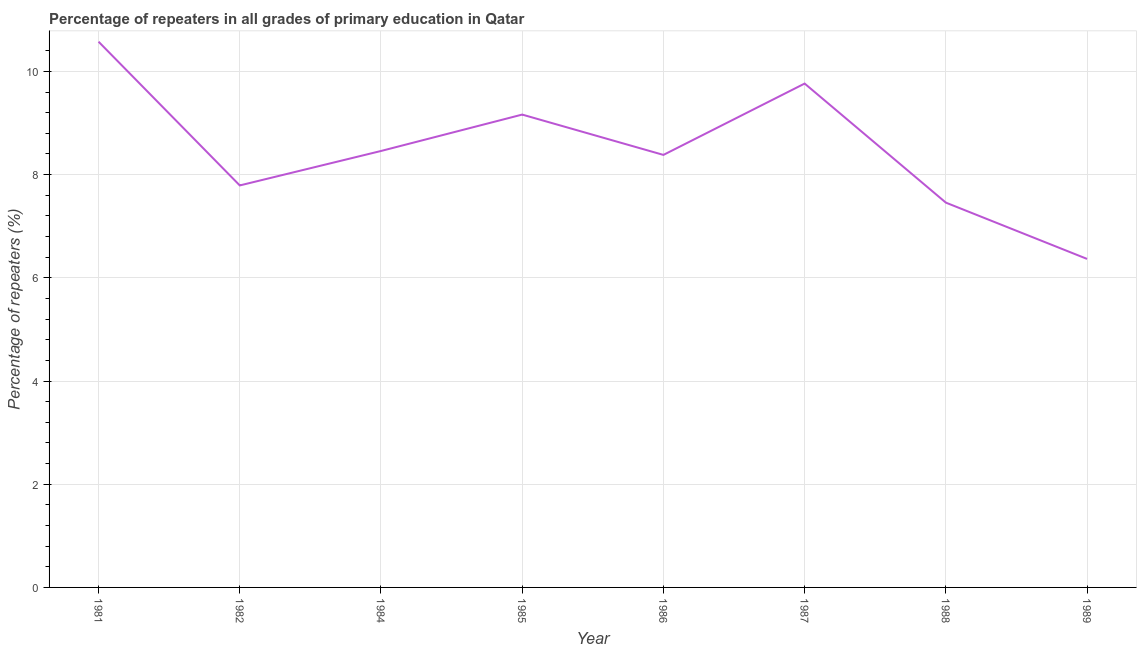What is the percentage of repeaters in primary education in 1986?
Provide a short and direct response. 8.38. Across all years, what is the maximum percentage of repeaters in primary education?
Your answer should be very brief. 10.58. Across all years, what is the minimum percentage of repeaters in primary education?
Provide a succinct answer. 6.37. In which year was the percentage of repeaters in primary education maximum?
Your answer should be very brief. 1981. What is the sum of the percentage of repeaters in primary education?
Keep it short and to the point. 67.96. What is the difference between the percentage of repeaters in primary education in 1984 and 1988?
Your response must be concise. 1. What is the average percentage of repeaters in primary education per year?
Provide a succinct answer. 8.49. What is the median percentage of repeaters in primary education?
Offer a very short reply. 8.42. What is the ratio of the percentage of repeaters in primary education in 1984 to that in 1987?
Your answer should be compact. 0.87. Is the percentage of repeaters in primary education in 1986 less than that in 1987?
Provide a succinct answer. Yes. Is the difference between the percentage of repeaters in primary education in 1982 and 1988 greater than the difference between any two years?
Offer a terse response. No. What is the difference between the highest and the second highest percentage of repeaters in primary education?
Provide a short and direct response. 0.81. What is the difference between the highest and the lowest percentage of repeaters in primary education?
Provide a succinct answer. 4.21. In how many years, is the percentage of repeaters in primary education greater than the average percentage of repeaters in primary education taken over all years?
Your answer should be compact. 3. Does the percentage of repeaters in primary education monotonically increase over the years?
Your answer should be very brief. No. Are the values on the major ticks of Y-axis written in scientific E-notation?
Provide a succinct answer. No. What is the title of the graph?
Make the answer very short. Percentage of repeaters in all grades of primary education in Qatar. What is the label or title of the X-axis?
Your answer should be compact. Year. What is the label or title of the Y-axis?
Offer a very short reply. Percentage of repeaters (%). What is the Percentage of repeaters (%) of 1981?
Provide a short and direct response. 10.58. What is the Percentage of repeaters (%) of 1982?
Provide a short and direct response. 7.79. What is the Percentage of repeaters (%) in 1984?
Offer a terse response. 8.46. What is the Percentage of repeaters (%) of 1985?
Give a very brief answer. 9.16. What is the Percentage of repeaters (%) of 1986?
Offer a terse response. 8.38. What is the Percentage of repeaters (%) of 1987?
Your response must be concise. 9.76. What is the Percentage of repeaters (%) in 1988?
Keep it short and to the point. 7.46. What is the Percentage of repeaters (%) in 1989?
Offer a terse response. 6.37. What is the difference between the Percentage of repeaters (%) in 1981 and 1982?
Keep it short and to the point. 2.79. What is the difference between the Percentage of repeaters (%) in 1981 and 1984?
Provide a succinct answer. 2.12. What is the difference between the Percentage of repeaters (%) in 1981 and 1985?
Your answer should be compact. 1.41. What is the difference between the Percentage of repeaters (%) in 1981 and 1986?
Offer a terse response. 2.19. What is the difference between the Percentage of repeaters (%) in 1981 and 1987?
Your response must be concise. 0.81. What is the difference between the Percentage of repeaters (%) in 1981 and 1988?
Give a very brief answer. 3.12. What is the difference between the Percentage of repeaters (%) in 1981 and 1989?
Offer a very short reply. 4.21. What is the difference between the Percentage of repeaters (%) in 1982 and 1984?
Give a very brief answer. -0.67. What is the difference between the Percentage of repeaters (%) in 1982 and 1985?
Give a very brief answer. -1.37. What is the difference between the Percentage of repeaters (%) in 1982 and 1986?
Give a very brief answer. -0.59. What is the difference between the Percentage of repeaters (%) in 1982 and 1987?
Offer a terse response. -1.97. What is the difference between the Percentage of repeaters (%) in 1982 and 1988?
Keep it short and to the point. 0.33. What is the difference between the Percentage of repeaters (%) in 1982 and 1989?
Offer a terse response. 1.42. What is the difference between the Percentage of repeaters (%) in 1984 and 1985?
Provide a short and direct response. -0.71. What is the difference between the Percentage of repeaters (%) in 1984 and 1986?
Keep it short and to the point. 0.08. What is the difference between the Percentage of repeaters (%) in 1984 and 1987?
Provide a succinct answer. -1.31. What is the difference between the Percentage of repeaters (%) in 1984 and 1988?
Your answer should be very brief. 1. What is the difference between the Percentage of repeaters (%) in 1984 and 1989?
Provide a short and direct response. 2.09. What is the difference between the Percentage of repeaters (%) in 1985 and 1986?
Your answer should be compact. 0.78. What is the difference between the Percentage of repeaters (%) in 1985 and 1987?
Keep it short and to the point. -0.6. What is the difference between the Percentage of repeaters (%) in 1985 and 1988?
Provide a succinct answer. 1.71. What is the difference between the Percentage of repeaters (%) in 1985 and 1989?
Keep it short and to the point. 2.8. What is the difference between the Percentage of repeaters (%) in 1986 and 1987?
Ensure brevity in your answer.  -1.38. What is the difference between the Percentage of repeaters (%) in 1986 and 1988?
Offer a terse response. 0.92. What is the difference between the Percentage of repeaters (%) in 1986 and 1989?
Your answer should be compact. 2.02. What is the difference between the Percentage of repeaters (%) in 1987 and 1988?
Give a very brief answer. 2.31. What is the difference between the Percentage of repeaters (%) in 1987 and 1989?
Give a very brief answer. 3.4. What is the difference between the Percentage of repeaters (%) in 1988 and 1989?
Offer a terse response. 1.09. What is the ratio of the Percentage of repeaters (%) in 1981 to that in 1982?
Offer a terse response. 1.36. What is the ratio of the Percentage of repeaters (%) in 1981 to that in 1985?
Make the answer very short. 1.15. What is the ratio of the Percentage of repeaters (%) in 1981 to that in 1986?
Offer a terse response. 1.26. What is the ratio of the Percentage of repeaters (%) in 1981 to that in 1987?
Offer a terse response. 1.08. What is the ratio of the Percentage of repeaters (%) in 1981 to that in 1988?
Offer a terse response. 1.42. What is the ratio of the Percentage of repeaters (%) in 1981 to that in 1989?
Offer a terse response. 1.66. What is the ratio of the Percentage of repeaters (%) in 1982 to that in 1984?
Make the answer very short. 0.92. What is the ratio of the Percentage of repeaters (%) in 1982 to that in 1986?
Ensure brevity in your answer.  0.93. What is the ratio of the Percentage of repeaters (%) in 1982 to that in 1987?
Offer a very short reply. 0.8. What is the ratio of the Percentage of repeaters (%) in 1982 to that in 1988?
Give a very brief answer. 1.04. What is the ratio of the Percentage of repeaters (%) in 1982 to that in 1989?
Your response must be concise. 1.22. What is the ratio of the Percentage of repeaters (%) in 1984 to that in 1985?
Provide a succinct answer. 0.92. What is the ratio of the Percentage of repeaters (%) in 1984 to that in 1987?
Your answer should be very brief. 0.87. What is the ratio of the Percentage of repeaters (%) in 1984 to that in 1988?
Your answer should be compact. 1.13. What is the ratio of the Percentage of repeaters (%) in 1984 to that in 1989?
Your answer should be very brief. 1.33. What is the ratio of the Percentage of repeaters (%) in 1985 to that in 1986?
Your answer should be compact. 1.09. What is the ratio of the Percentage of repeaters (%) in 1985 to that in 1987?
Ensure brevity in your answer.  0.94. What is the ratio of the Percentage of repeaters (%) in 1985 to that in 1988?
Provide a short and direct response. 1.23. What is the ratio of the Percentage of repeaters (%) in 1985 to that in 1989?
Keep it short and to the point. 1.44. What is the ratio of the Percentage of repeaters (%) in 1986 to that in 1987?
Your answer should be very brief. 0.86. What is the ratio of the Percentage of repeaters (%) in 1986 to that in 1988?
Make the answer very short. 1.12. What is the ratio of the Percentage of repeaters (%) in 1986 to that in 1989?
Offer a very short reply. 1.32. What is the ratio of the Percentage of repeaters (%) in 1987 to that in 1988?
Provide a short and direct response. 1.31. What is the ratio of the Percentage of repeaters (%) in 1987 to that in 1989?
Offer a very short reply. 1.53. What is the ratio of the Percentage of repeaters (%) in 1988 to that in 1989?
Offer a very short reply. 1.17. 